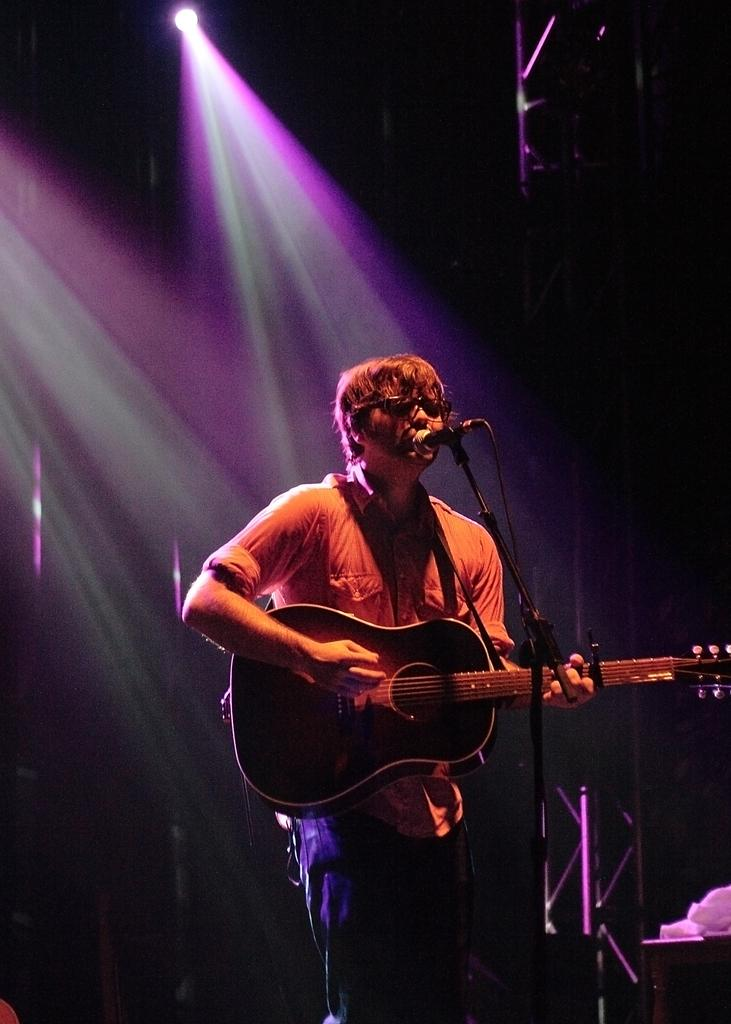What is the main subject of the image? There is a person in the image. What is the person doing in the image? The person is standing in the image. What object is the person holding in the image? The person is holding a guitar in his hand. What type of zebra can be seen rubbing a brick against the guitar in the image? There is no zebra or brick present in the image. The person is holding a guitar, but there is no interaction with a zebra or a brick. 